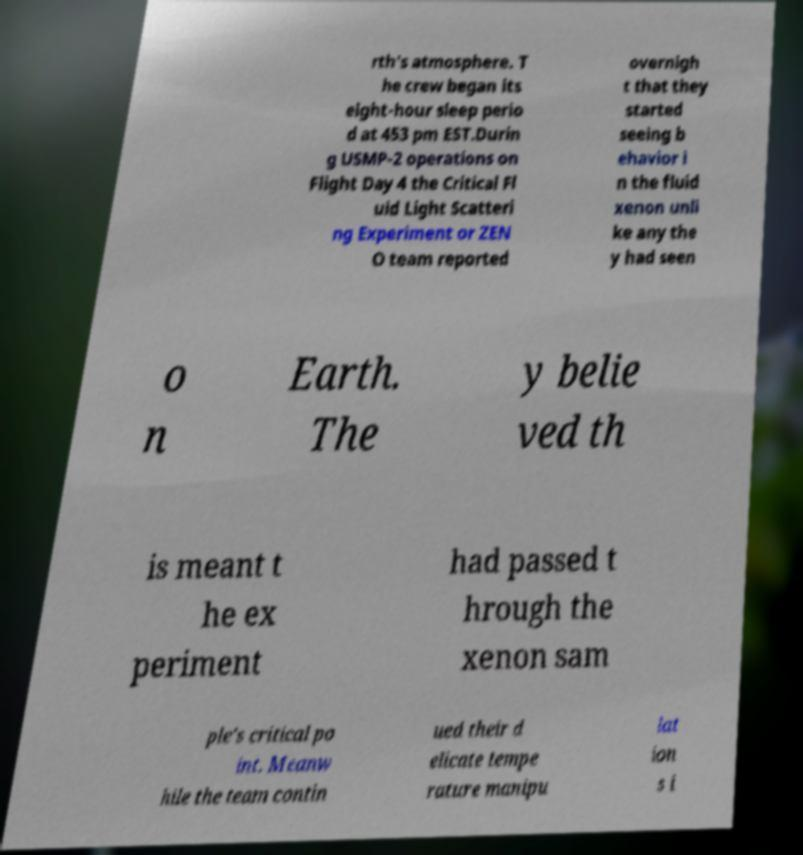Can you accurately transcribe the text from the provided image for me? rth's atmosphere. T he crew began its eight-hour sleep perio d at 453 pm EST.Durin g USMP-2 operations on Flight Day 4 the Critical Fl uid Light Scatteri ng Experiment or ZEN O team reported overnigh t that they started seeing b ehavior i n the fluid xenon unli ke any the y had seen o n Earth. The y belie ved th is meant t he ex periment had passed t hrough the xenon sam ple's critical po int. Meanw hile the team contin ued their d elicate tempe rature manipu lat ion s i 